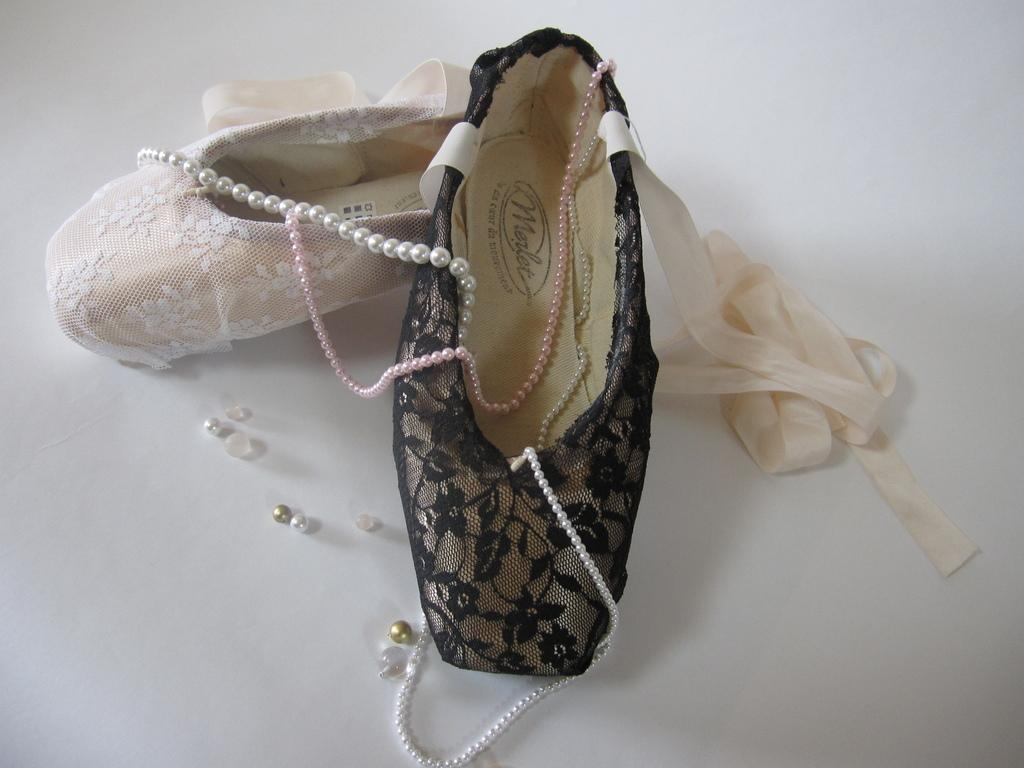What is placed on the floor in the image? There is a pair of shoes on the floor in the image. What type of accessory is visible in the image? There is a necklace present in the image. What subject is being taught in the image? There is no indication of any teaching or subject being taught in the image. What is the fifth item in the image? There are only two items mentioned in the facts (pair of shoes and necklace), so there is no fifth item to identify. 